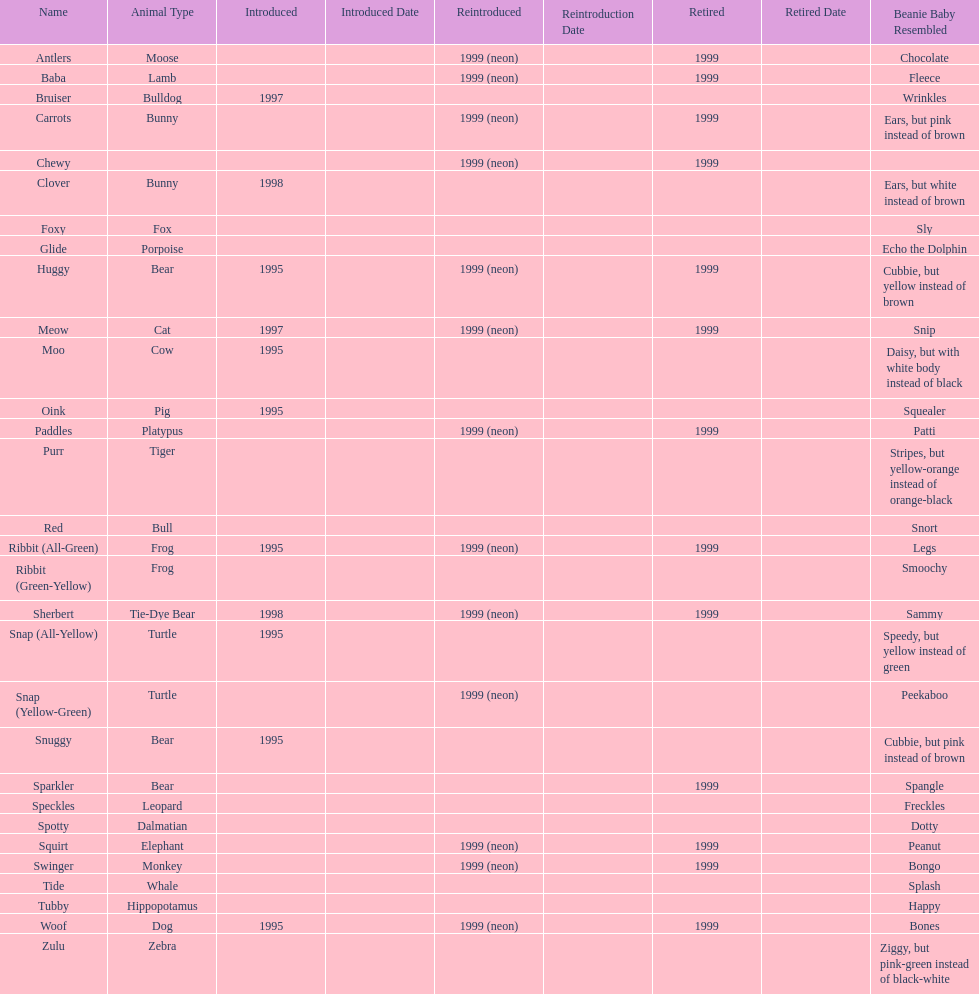What is the number of frog pillow pals? 2. 